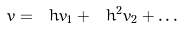Convert formula to latex. <formula><loc_0><loc_0><loc_500><loc_500>v = \ h v _ { 1 } + \ h ^ { 2 } v _ { 2 } + \dots</formula> 